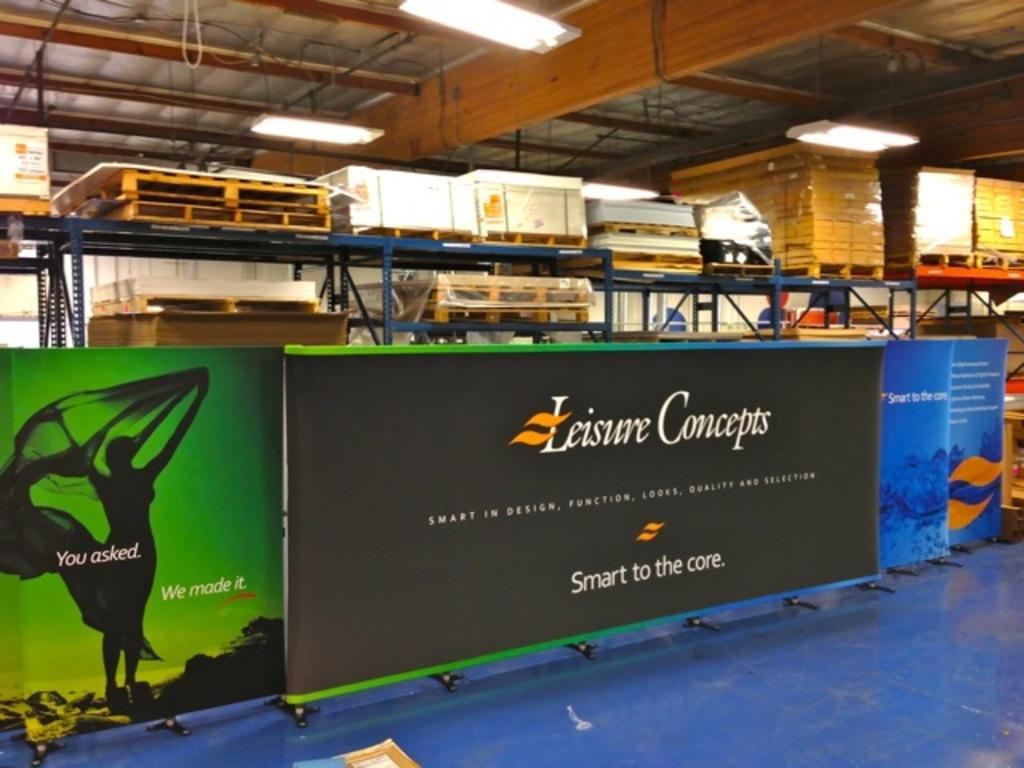<image>
Provide a brief description of the given image. A leisure concepts billboard is prepared to be hung up. 